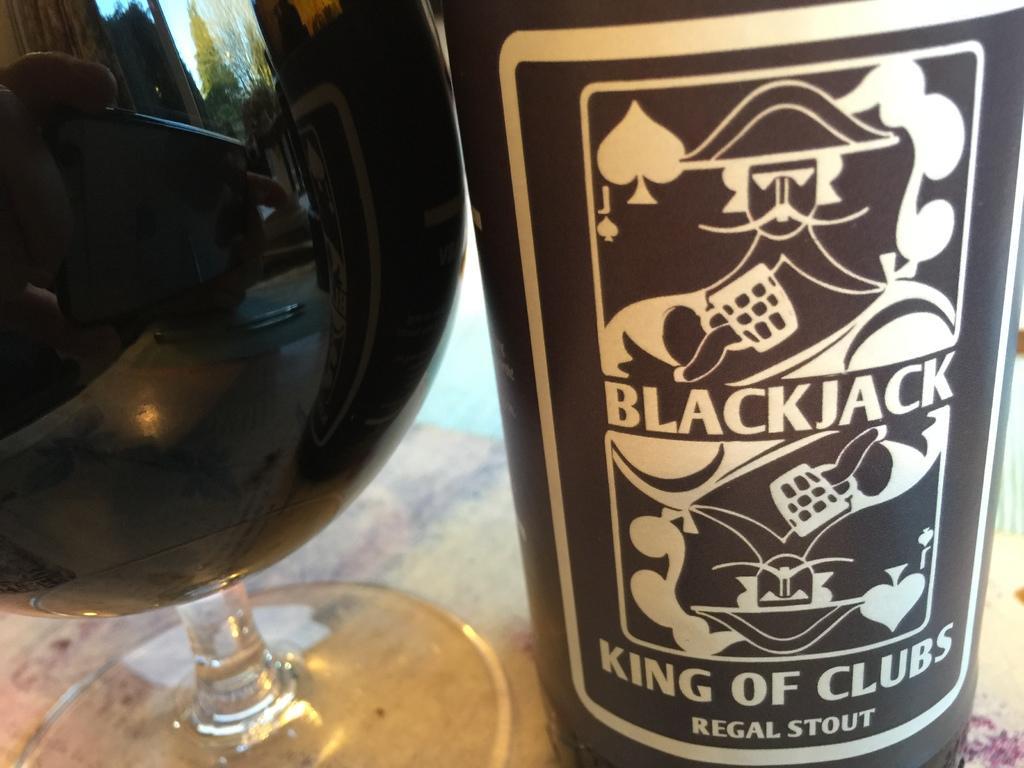How would you summarize this image in a sentence or two? In this image there is one bottle and glass and in the glass it seems that there is some drink, and through the glass we could see some trees, people sitting on couch and some objects. On the bottle there is a label, on the label there is text. And at the bottom it looks like a table. 